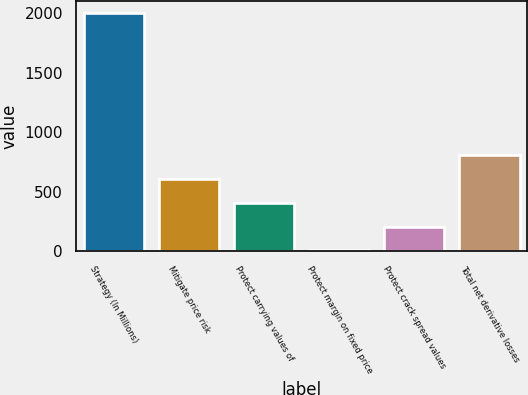Convert chart. <chart><loc_0><loc_0><loc_500><loc_500><bar_chart><fcel>Strategy (In Millions)<fcel>Mitigate price risk<fcel>Protect carrying values of<fcel>Protect margin on fixed price<fcel>Protect crack spread values<fcel>Total net derivative losses<nl><fcel>2004<fcel>606.8<fcel>407.2<fcel>8<fcel>207.6<fcel>806.4<nl></chart> 